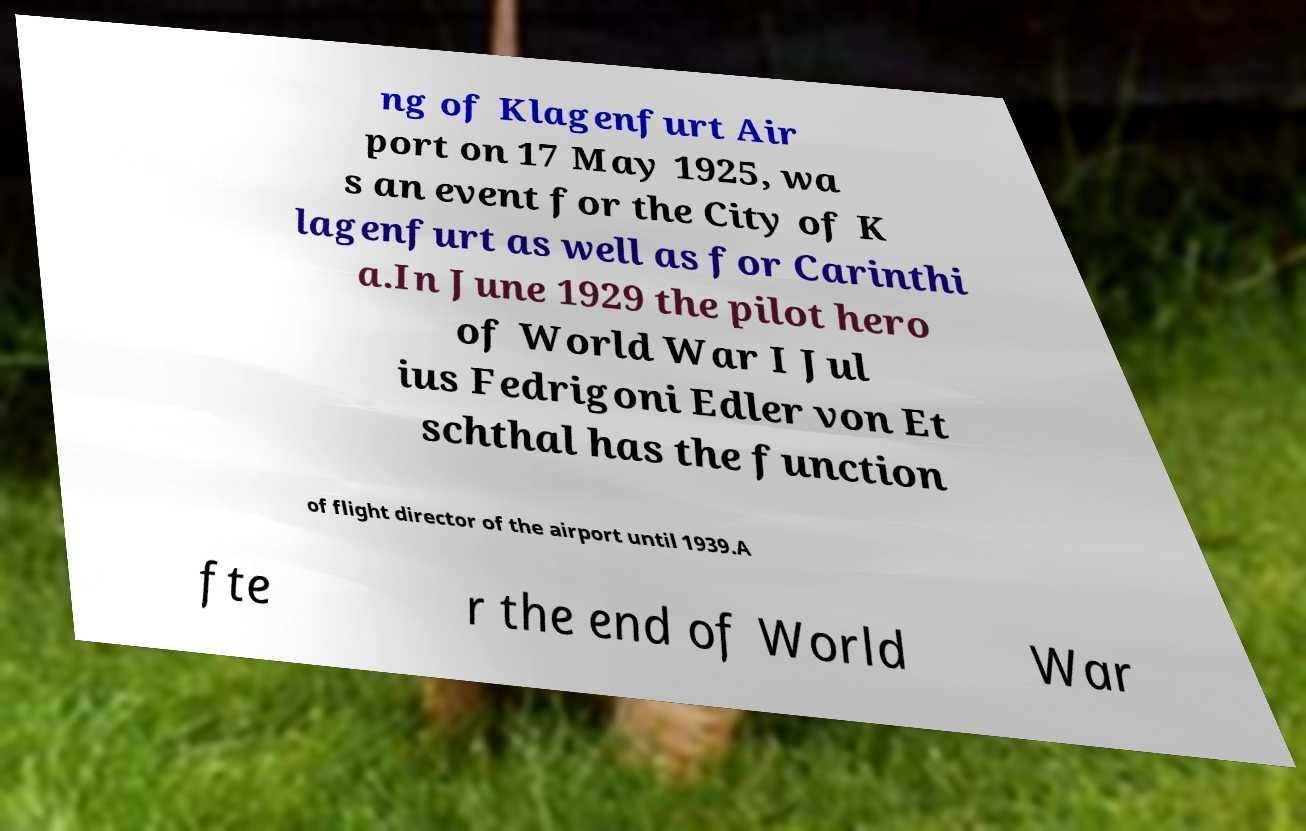I need the written content from this picture converted into text. Can you do that? ng of Klagenfurt Air port on 17 May 1925, wa s an event for the City of K lagenfurt as well as for Carinthi a.In June 1929 the pilot hero of World War I Jul ius Fedrigoni Edler von Et schthal has the function of flight director of the airport until 1939.A fte r the end of World War 